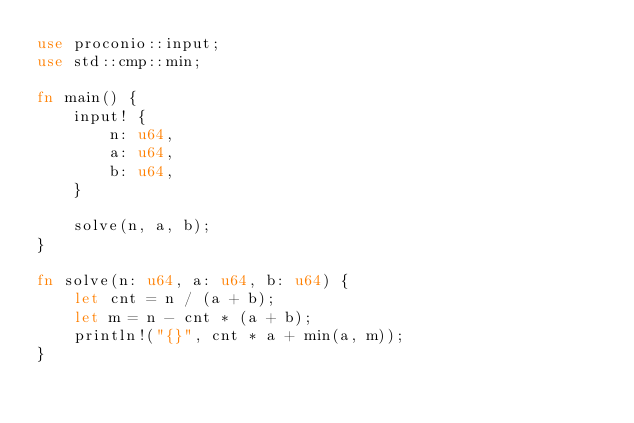Convert code to text. <code><loc_0><loc_0><loc_500><loc_500><_Rust_>use proconio::input;
use std::cmp::min;

fn main() {
    input! {
        n: u64,
        a: u64,
        b: u64,
    }

    solve(n, a, b);
}

fn solve(n: u64, a: u64, b: u64) {
    let cnt = n / (a + b);
    let m = n - cnt * (a + b);
    println!("{}", cnt * a + min(a, m));
}
</code> 